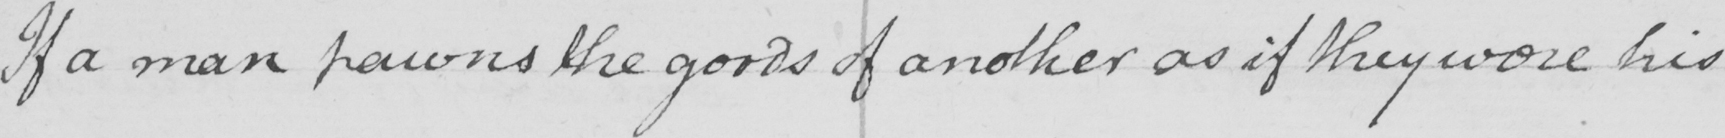Can you tell me what this handwritten text says? If a man pawns the goods of another as if they were his 